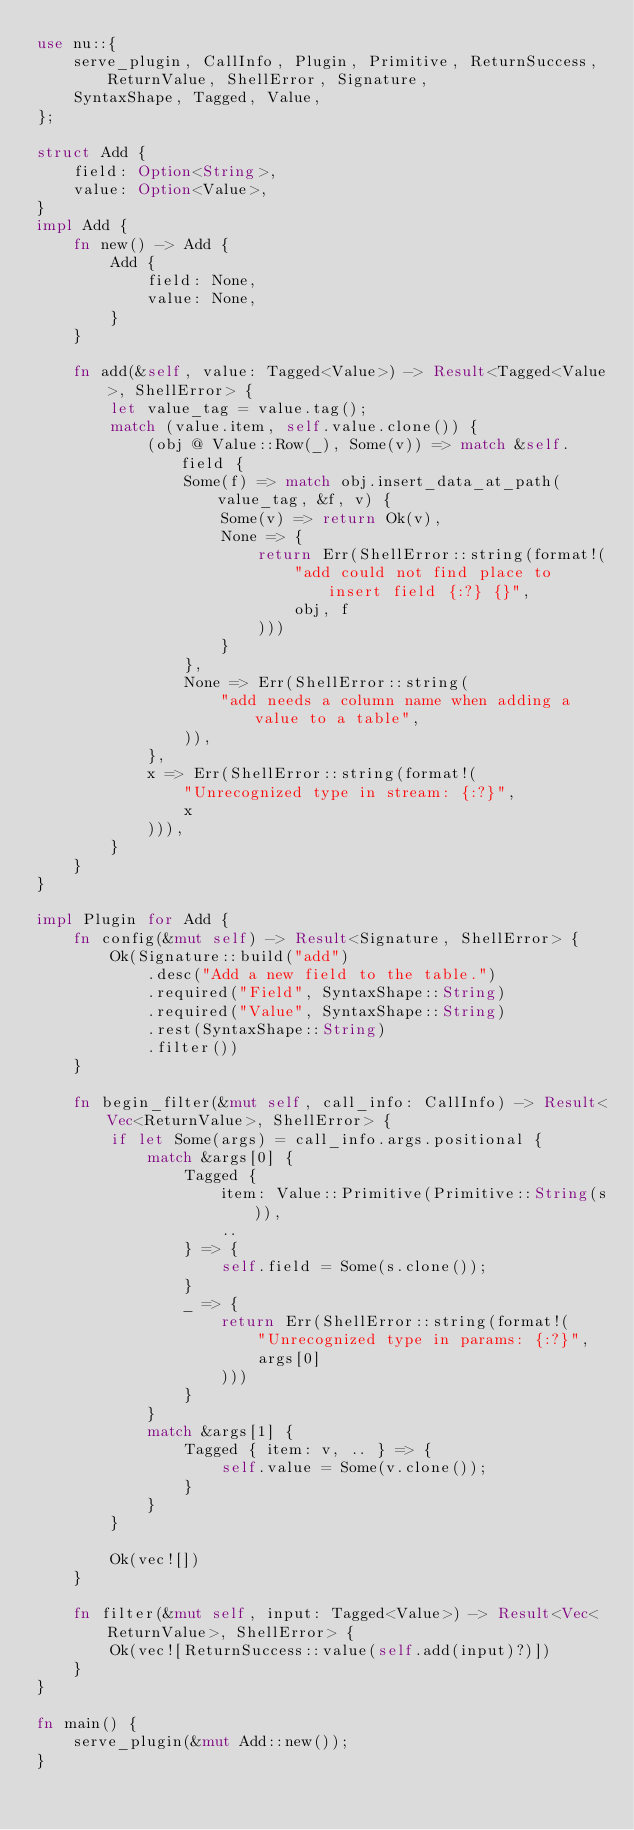<code> <loc_0><loc_0><loc_500><loc_500><_Rust_>use nu::{
    serve_plugin, CallInfo, Plugin, Primitive, ReturnSuccess, ReturnValue, ShellError, Signature,
    SyntaxShape, Tagged, Value,
};

struct Add {
    field: Option<String>,
    value: Option<Value>,
}
impl Add {
    fn new() -> Add {
        Add {
            field: None,
            value: None,
        }
    }

    fn add(&self, value: Tagged<Value>) -> Result<Tagged<Value>, ShellError> {
        let value_tag = value.tag();
        match (value.item, self.value.clone()) {
            (obj @ Value::Row(_), Some(v)) => match &self.field {
                Some(f) => match obj.insert_data_at_path(value_tag, &f, v) {
                    Some(v) => return Ok(v),
                    None => {
                        return Err(ShellError::string(format!(
                            "add could not find place to insert field {:?} {}",
                            obj, f
                        )))
                    }
                },
                None => Err(ShellError::string(
                    "add needs a column name when adding a value to a table",
                )),
            },
            x => Err(ShellError::string(format!(
                "Unrecognized type in stream: {:?}",
                x
            ))),
        }
    }
}

impl Plugin for Add {
    fn config(&mut self) -> Result<Signature, ShellError> {
        Ok(Signature::build("add")
            .desc("Add a new field to the table.")
            .required("Field", SyntaxShape::String)
            .required("Value", SyntaxShape::String)
            .rest(SyntaxShape::String)
            .filter())
    }

    fn begin_filter(&mut self, call_info: CallInfo) -> Result<Vec<ReturnValue>, ShellError> {
        if let Some(args) = call_info.args.positional {
            match &args[0] {
                Tagged {
                    item: Value::Primitive(Primitive::String(s)),
                    ..
                } => {
                    self.field = Some(s.clone());
                }
                _ => {
                    return Err(ShellError::string(format!(
                        "Unrecognized type in params: {:?}",
                        args[0]
                    )))
                }
            }
            match &args[1] {
                Tagged { item: v, .. } => {
                    self.value = Some(v.clone());
                }
            }
        }

        Ok(vec![])
    }

    fn filter(&mut self, input: Tagged<Value>) -> Result<Vec<ReturnValue>, ShellError> {
        Ok(vec![ReturnSuccess::value(self.add(input)?)])
    }
}

fn main() {
    serve_plugin(&mut Add::new());
}
</code> 